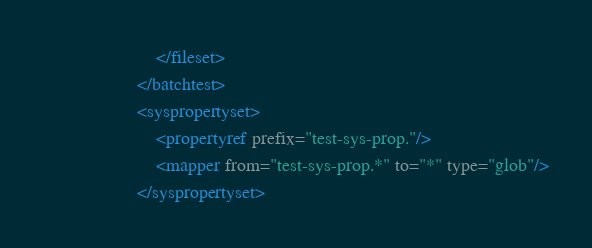Convert code to text. <code><loc_0><loc_0><loc_500><loc_500><_XML_>                        </fileset>
                    </batchtest>
                    <syspropertyset>
                        <propertyref prefix="test-sys-prop."/>
                        <mapper from="test-sys-prop.*" to="*" type="glob"/>
                    </syspropertyset></code> 